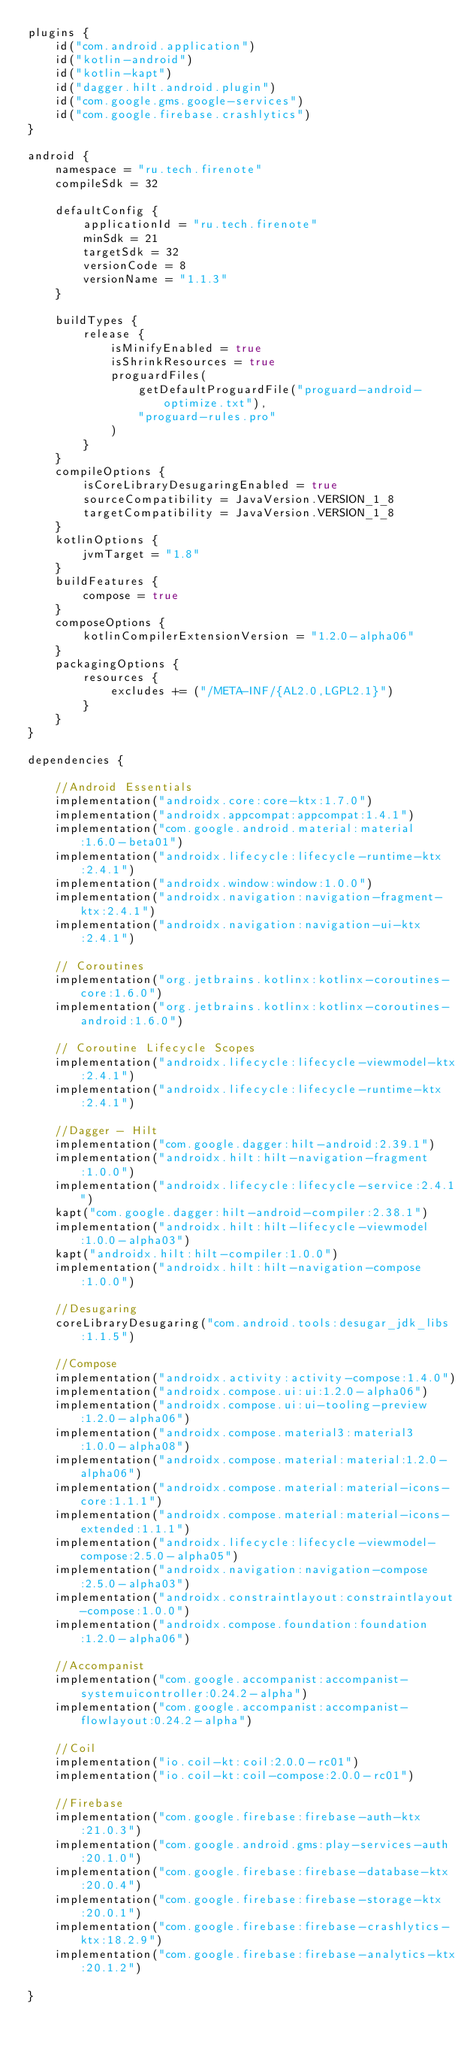Convert code to text. <code><loc_0><loc_0><loc_500><loc_500><_Kotlin_>plugins {
    id("com.android.application")
    id("kotlin-android")
    id("kotlin-kapt")
    id("dagger.hilt.android.plugin")
    id("com.google.gms.google-services")
    id("com.google.firebase.crashlytics")
}

android {
    namespace = "ru.tech.firenote"
    compileSdk = 32

    defaultConfig {
        applicationId = "ru.tech.firenote"
        minSdk = 21
        targetSdk = 32
        versionCode = 8
        versionName = "1.1.3"
    }

    buildTypes {
        release {
            isMinifyEnabled = true
            isShrinkResources = true
            proguardFiles(
                getDefaultProguardFile("proguard-android-optimize.txt"),
                "proguard-rules.pro"
            )
        }
    }
    compileOptions {
        isCoreLibraryDesugaringEnabled = true
        sourceCompatibility = JavaVersion.VERSION_1_8
        targetCompatibility = JavaVersion.VERSION_1_8
    }
    kotlinOptions {
        jvmTarget = "1.8"
    }
    buildFeatures {
        compose = true
    }
    composeOptions {
        kotlinCompilerExtensionVersion = "1.2.0-alpha06"
    }
    packagingOptions {
        resources {
            excludes += ("/META-INF/{AL2.0,LGPL2.1}")
        }
    }
}

dependencies {

    //Android Essentials
    implementation("androidx.core:core-ktx:1.7.0")
    implementation("androidx.appcompat:appcompat:1.4.1")
    implementation("com.google.android.material:material:1.6.0-beta01")
    implementation("androidx.lifecycle:lifecycle-runtime-ktx:2.4.1")
    implementation("androidx.window:window:1.0.0")
    implementation("androidx.navigation:navigation-fragment-ktx:2.4.1")
    implementation("androidx.navigation:navigation-ui-ktx:2.4.1")

    // Coroutines
    implementation("org.jetbrains.kotlinx:kotlinx-coroutines-core:1.6.0")
    implementation("org.jetbrains.kotlinx:kotlinx-coroutines-android:1.6.0")

    // Coroutine Lifecycle Scopes
    implementation("androidx.lifecycle:lifecycle-viewmodel-ktx:2.4.1")
    implementation("androidx.lifecycle:lifecycle-runtime-ktx:2.4.1")

    //Dagger - Hilt
    implementation("com.google.dagger:hilt-android:2.39.1")
    implementation("androidx.hilt:hilt-navigation-fragment:1.0.0")
    implementation("androidx.lifecycle:lifecycle-service:2.4.1")
    kapt("com.google.dagger:hilt-android-compiler:2.38.1")
    implementation("androidx.hilt:hilt-lifecycle-viewmodel:1.0.0-alpha03")
    kapt("androidx.hilt:hilt-compiler:1.0.0")
    implementation("androidx.hilt:hilt-navigation-compose:1.0.0")

    //Desugaring
    coreLibraryDesugaring("com.android.tools:desugar_jdk_libs:1.1.5")

    //Compose
    implementation("androidx.activity:activity-compose:1.4.0")
    implementation("androidx.compose.ui:ui:1.2.0-alpha06")
    implementation("androidx.compose.ui:ui-tooling-preview:1.2.0-alpha06")
    implementation("androidx.compose.material3:material3:1.0.0-alpha08")
    implementation("androidx.compose.material:material:1.2.0-alpha06")
    implementation("androidx.compose.material:material-icons-core:1.1.1")
    implementation("androidx.compose.material:material-icons-extended:1.1.1")
    implementation("androidx.lifecycle:lifecycle-viewmodel-compose:2.5.0-alpha05")
    implementation("androidx.navigation:navigation-compose:2.5.0-alpha03")
    implementation("androidx.constraintlayout:constraintlayout-compose:1.0.0")
    implementation("androidx.compose.foundation:foundation:1.2.0-alpha06")

    //Accompanist
    implementation("com.google.accompanist:accompanist-systemuicontroller:0.24.2-alpha")
    implementation("com.google.accompanist:accompanist-flowlayout:0.24.2-alpha")

    //Coil
    implementation("io.coil-kt:coil:2.0.0-rc01")
    implementation("io.coil-kt:coil-compose:2.0.0-rc01")

    //Firebase
    implementation("com.google.firebase:firebase-auth-ktx:21.0.3")
    implementation("com.google.android.gms:play-services-auth:20.1.0")
    implementation("com.google.firebase:firebase-database-ktx:20.0.4")
    implementation("com.google.firebase:firebase-storage-ktx:20.0.1")
    implementation("com.google.firebase:firebase-crashlytics-ktx:18.2.9")
    implementation("com.google.firebase:firebase-analytics-ktx:20.1.2")

}</code> 